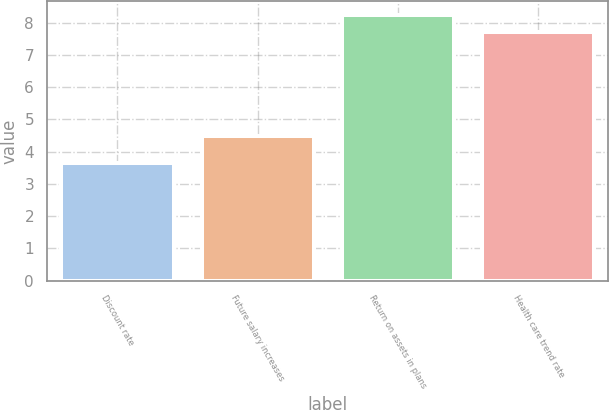<chart> <loc_0><loc_0><loc_500><loc_500><bar_chart><fcel>Discount rate<fcel>Future salary increases<fcel>Return on assets in plans<fcel>Health care trend rate<nl><fcel>3.65<fcel>4.5<fcel>8.25<fcel>7.7<nl></chart> 